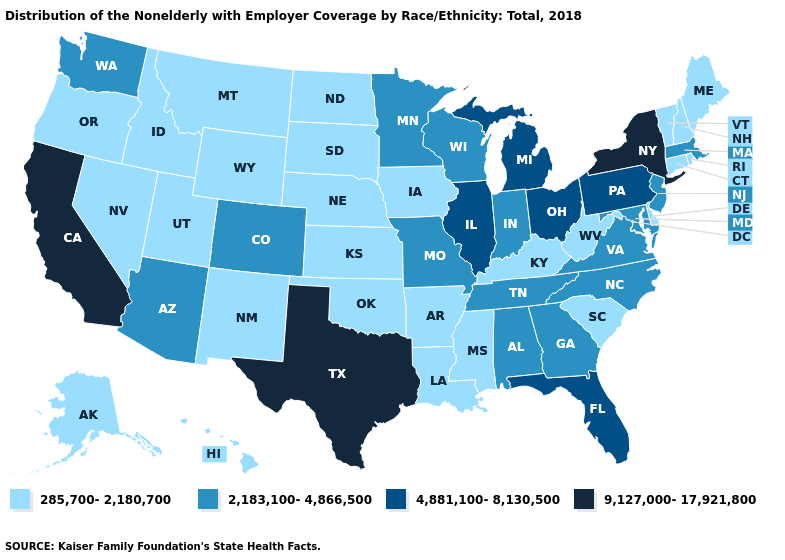What is the value of Hawaii?
Give a very brief answer. 285,700-2,180,700. Does Rhode Island have the lowest value in the USA?
Answer briefly. Yes. Does New York have the highest value in the USA?
Write a very short answer. Yes. Name the states that have a value in the range 9,127,000-17,921,800?
Answer briefly. California, New York, Texas. Name the states that have a value in the range 285,700-2,180,700?
Quick response, please. Alaska, Arkansas, Connecticut, Delaware, Hawaii, Idaho, Iowa, Kansas, Kentucky, Louisiana, Maine, Mississippi, Montana, Nebraska, Nevada, New Hampshire, New Mexico, North Dakota, Oklahoma, Oregon, Rhode Island, South Carolina, South Dakota, Utah, Vermont, West Virginia, Wyoming. Name the states that have a value in the range 9,127,000-17,921,800?
Answer briefly. California, New York, Texas. What is the value of Pennsylvania?
Be succinct. 4,881,100-8,130,500. What is the lowest value in the USA?
Give a very brief answer. 285,700-2,180,700. Name the states that have a value in the range 4,881,100-8,130,500?
Quick response, please. Florida, Illinois, Michigan, Ohio, Pennsylvania. Which states have the lowest value in the Northeast?
Keep it brief. Connecticut, Maine, New Hampshire, Rhode Island, Vermont. Among the states that border Vermont , does New York have the highest value?
Concise answer only. Yes. Name the states that have a value in the range 9,127,000-17,921,800?
Short answer required. California, New York, Texas. Name the states that have a value in the range 4,881,100-8,130,500?
Quick response, please. Florida, Illinois, Michigan, Ohio, Pennsylvania. What is the value of California?
Answer briefly. 9,127,000-17,921,800. What is the value of Iowa?
Concise answer only. 285,700-2,180,700. 